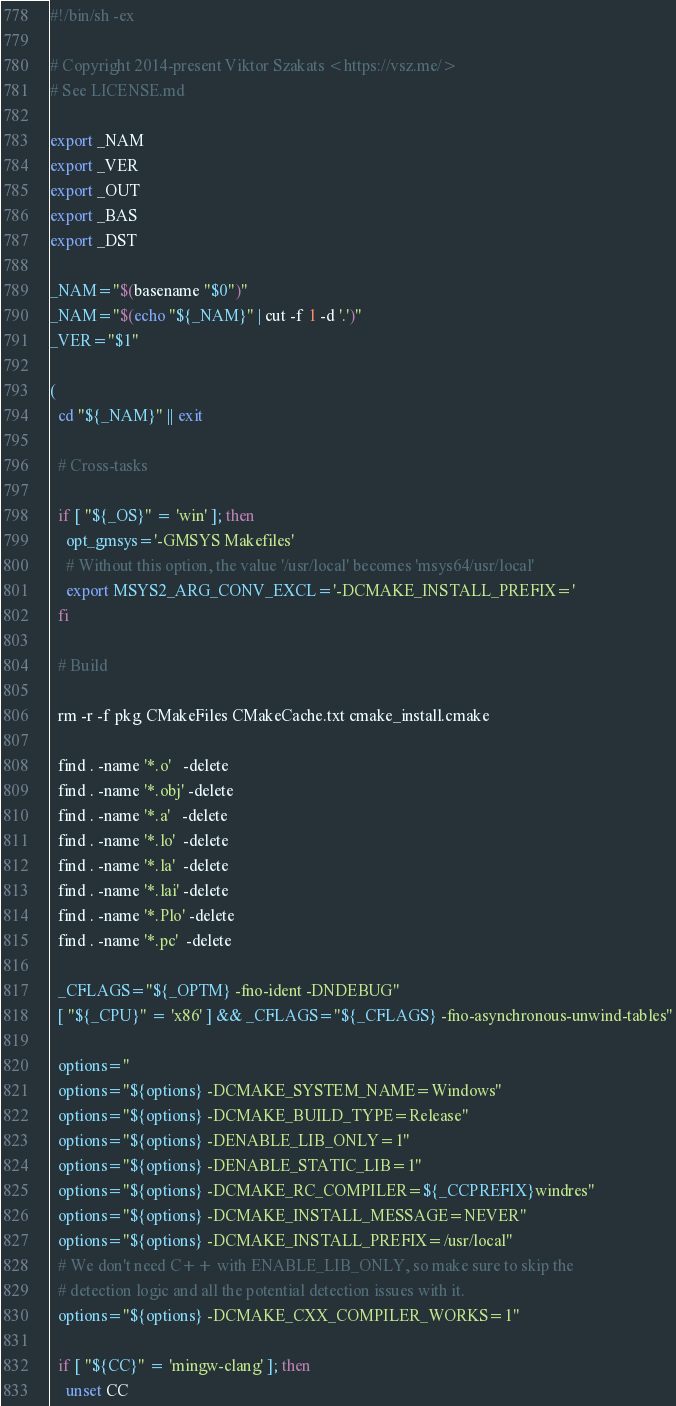<code> <loc_0><loc_0><loc_500><loc_500><_Bash_>#!/bin/sh -ex

# Copyright 2014-present Viktor Szakats <https://vsz.me/>
# See LICENSE.md

export _NAM
export _VER
export _OUT
export _BAS
export _DST

_NAM="$(basename "$0")"
_NAM="$(echo "${_NAM}" | cut -f 1 -d '.')"
_VER="$1"

(
  cd "${_NAM}" || exit

  # Cross-tasks

  if [ "${_OS}" = 'win' ]; then
    opt_gmsys='-GMSYS Makefiles'
    # Without this option, the value '/usr/local' becomes 'msys64/usr/local'
    export MSYS2_ARG_CONV_EXCL='-DCMAKE_INSTALL_PREFIX='
  fi

  # Build

  rm -r -f pkg CMakeFiles CMakeCache.txt cmake_install.cmake

  find . -name '*.o'   -delete
  find . -name '*.obj' -delete
  find . -name '*.a'   -delete
  find . -name '*.lo'  -delete
  find . -name '*.la'  -delete
  find . -name '*.lai' -delete
  find . -name '*.Plo' -delete
  find . -name '*.pc'  -delete

  _CFLAGS="${_OPTM} -fno-ident -DNDEBUG"
  [ "${_CPU}" = 'x86' ] && _CFLAGS="${_CFLAGS} -fno-asynchronous-unwind-tables"

  options=''
  options="${options} -DCMAKE_SYSTEM_NAME=Windows"
  options="${options} -DCMAKE_BUILD_TYPE=Release"
  options="${options} -DENABLE_LIB_ONLY=1"
  options="${options} -DENABLE_STATIC_LIB=1"
  options="${options} -DCMAKE_RC_COMPILER=${_CCPREFIX}windres"
  options="${options} -DCMAKE_INSTALL_MESSAGE=NEVER"
  options="${options} -DCMAKE_INSTALL_PREFIX=/usr/local"
  # We don't need C++ with ENABLE_LIB_ONLY, so make sure to skip the
  # detection logic and all the potential detection issues with it.
  options="${options} -DCMAKE_CXX_COMPILER_WORKS=1"

  if [ "${CC}" = 'mingw-clang' ]; then
    unset CC
</code> 